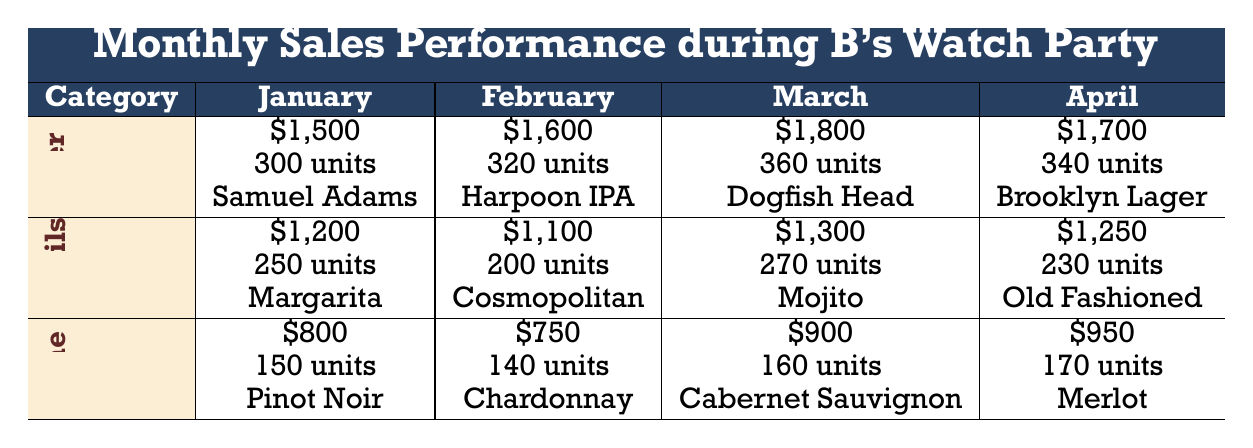What was the highest sales amount for beer during the watch party? Looking at the beer sales amounts for each month, January has 1500, February has 1600, March has 1800, and April has 1700. March has the highest sales figure at 1800.
Answer: 1800 Which cocktail sold the most units in January? For January, the cocktail sales show Margarita with 250 units sold. By examining the table, it's clear Margarita had the most units sold that month compared to others.
Answer: Margarita In which month did wine sales exceed 900 dollars? By reviewing the wine sales across the months, January had 800, February had 750, March had 900, and April had 950. The sales only exceeded 900 in April with 950.
Answer: April How much more did beer sell than cocktails in March? In March, beer sales amounted to 1800 and cocktail sales were 1300. Calculating the difference: 1800 - 1300 = 500, so beer sold 500 more than cocktails.
Answer: 500 Did the sales amount for cocktails increase from January to February? By comparing the sales amounts, January showed 1200 dollars for cocktails and February showed 1100 dollars. Since 1100 is lower than 1200, the sales amount for cocktails decreased instead.
Answer: No What is the total sales amount for all drink categories in April? The sales amounts for April are 1700 for beer, 1250 for cocktails, and 950 for wine. Adding these: 1700 + 1250 + 950 = 3900 gives a total sales amount for April.
Answer: 3900 Which drink category had the highest total units sold across all months? To find the total units sold, I add up the beer (300 + 320 + 360 + 340), cocktails (250 + 200 + 270 + 230), and wine (150 + 140 + 160 + 170). Beer totals 1300, cocktails total 950, and wine totals 620, thus beer had the highest total units sold at 1300.
Answer: Beer Which was the top-selling wine in March? For March, the wine sales highlight Cabernet Sauvignon as the top product under the wine category, showing the specific product sold that month.
Answer: Cabernet Sauvignon In which month did 'Old Fashioned' become the top cocktail? Looking at the cocktail top products for each month, Old Fashioned appears in April. Therefore, it became the top cocktail in that month.
Answer: April 